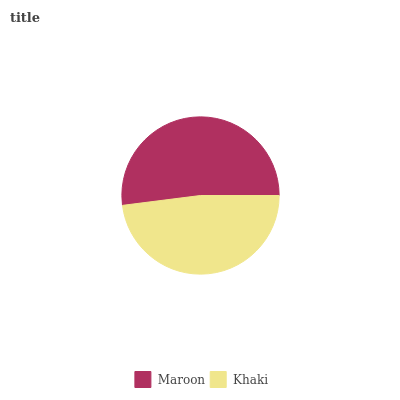Is Khaki the minimum?
Answer yes or no. Yes. Is Maroon the maximum?
Answer yes or no. Yes. Is Khaki the maximum?
Answer yes or no. No. Is Maroon greater than Khaki?
Answer yes or no. Yes. Is Khaki less than Maroon?
Answer yes or no. Yes. Is Khaki greater than Maroon?
Answer yes or no. No. Is Maroon less than Khaki?
Answer yes or no. No. Is Maroon the high median?
Answer yes or no. Yes. Is Khaki the low median?
Answer yes or no. Yes. Is Khaki the high median?
Answer yes or no. No. Is Maroon the low median?
Answer yes or no. No. 